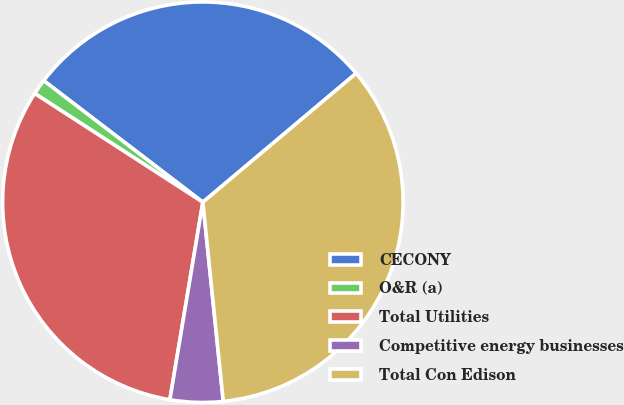<chart> <loc_0><loc_0><loc_500><loc_500><pie_chart><fcel>CECONY<fcel>O&R (a)<fcel>Total Utilities<fcel>Competitive energy businesses<fcel>Total Con Edison<nl><fcel>28.49%<fcel>1.25%<fcel>31.5%<fcel>4.26%<fcel>34.5%<nl></chart> 